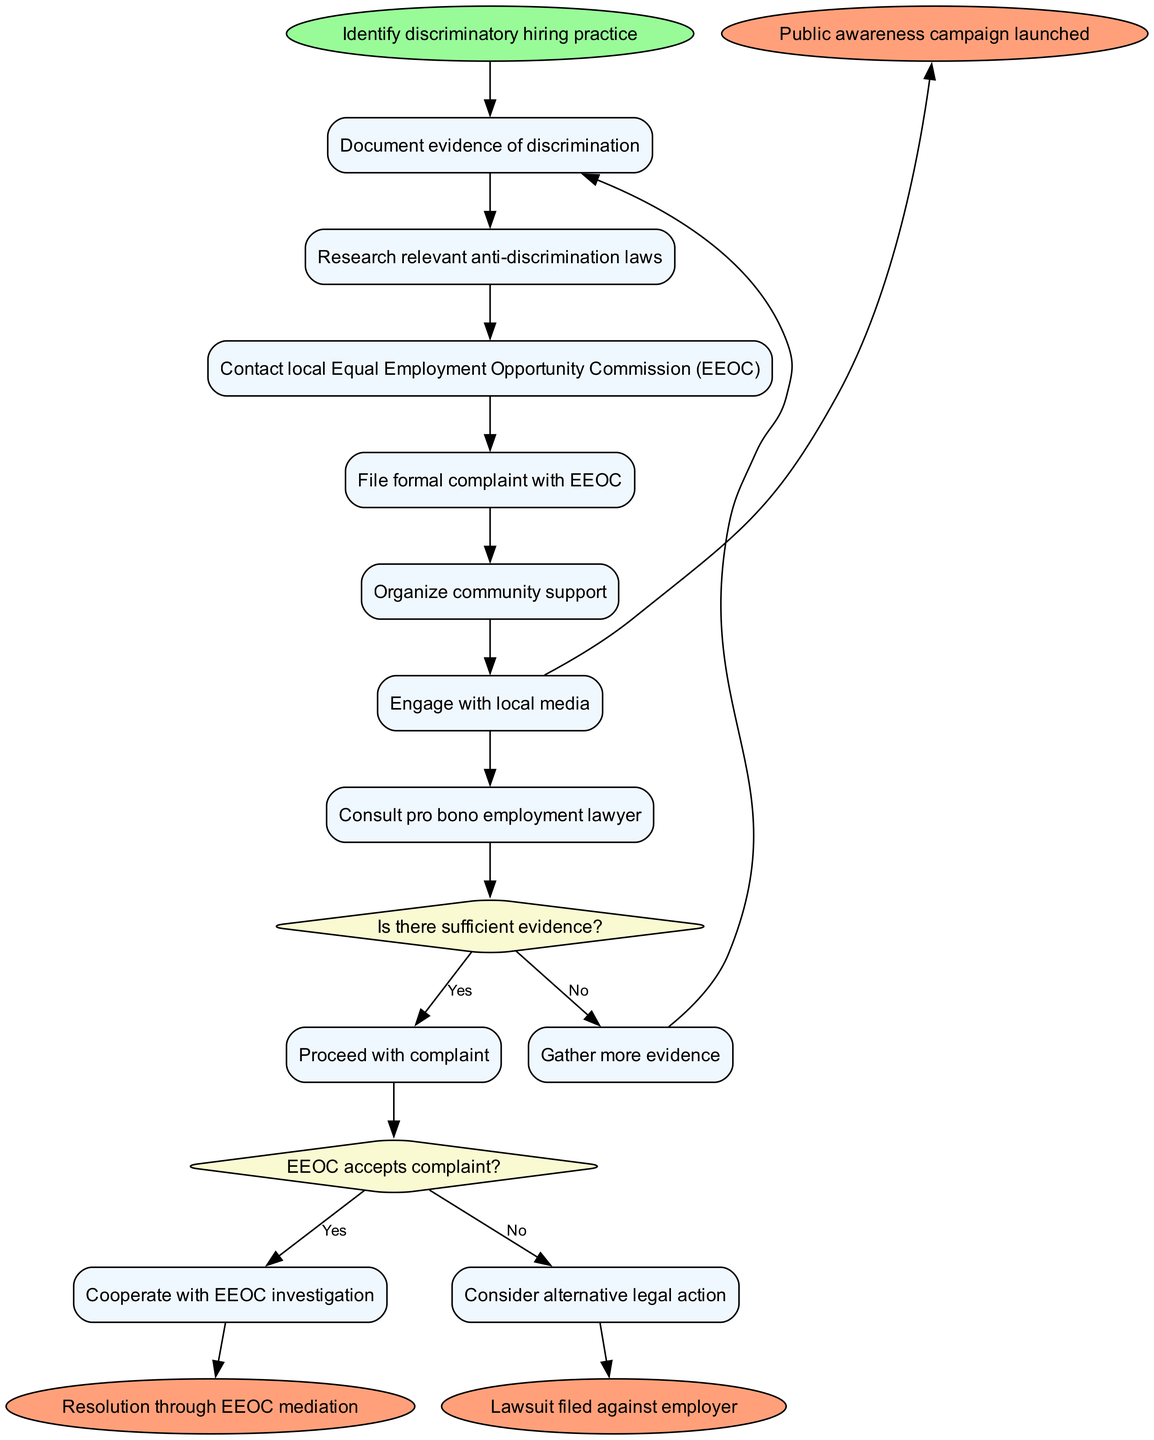What is the starting activity in the diagram? The starting activity named "Identify discriminatory hiring practice" is explicitly labeled at the beginning of the diagram. It is represented as the starting node before any other activities or decisions.
Answer: Identify discriminatory hiring practice How many activity nodes are present in the diagram? The diagram contains six activity nodes listed under "activities." They include steps like documenting evidence and contacting the EEOC. Counting these gives a total of six activity nodes.
Answer: 6 What decision follows the last activity? The last activity, "Consult pro bono employment lawyer," is connected to the decision point represented by the question "Is there sufficient evidence?" This decision follows the flow directly after the final activity node.
Answer: Is there sufficient evidence? What happens if the EEOC accepts the complaint? If the EEOC accepts the complaint, per the diagram, the next action taken is "Cooperate with EEOC investigation." This is the positive outcome connected to the decision point regarding the acceptance of the complaint.
Answer: Cooperate with EEOC investigation If there is not enough evidence, what action should be taken? When there is insufficient evidence, the diagram instructs to "Gather more evidence." This response is directly linked from the decision point that evaluates the adequacy of evidence.
Answer: Gather more evidence How many end nodes are there in the diagram? The diagram concludes with three end nodes, which represent the final outcomes of the process. These end nodes show different resolutions emerging from the complaint process.
Answer: 3 What is a potential outcome if the complaint is not accepted by the EEOC? If the EEOC does not accept the complaint, the diagram indicates that one option is to "Consider alternative legal action." This decision stems from the rejection of the complaint.
Answer: Consider alternative legal action Which activity connects to the "Public awareness campaign launched" end node? The end node "Public awareness campaign launched" connects to the activity "Engage with local media." This shows that engaging with the media can lead to raising public awareness as a potential outcome.
Answer: Engage with local media 